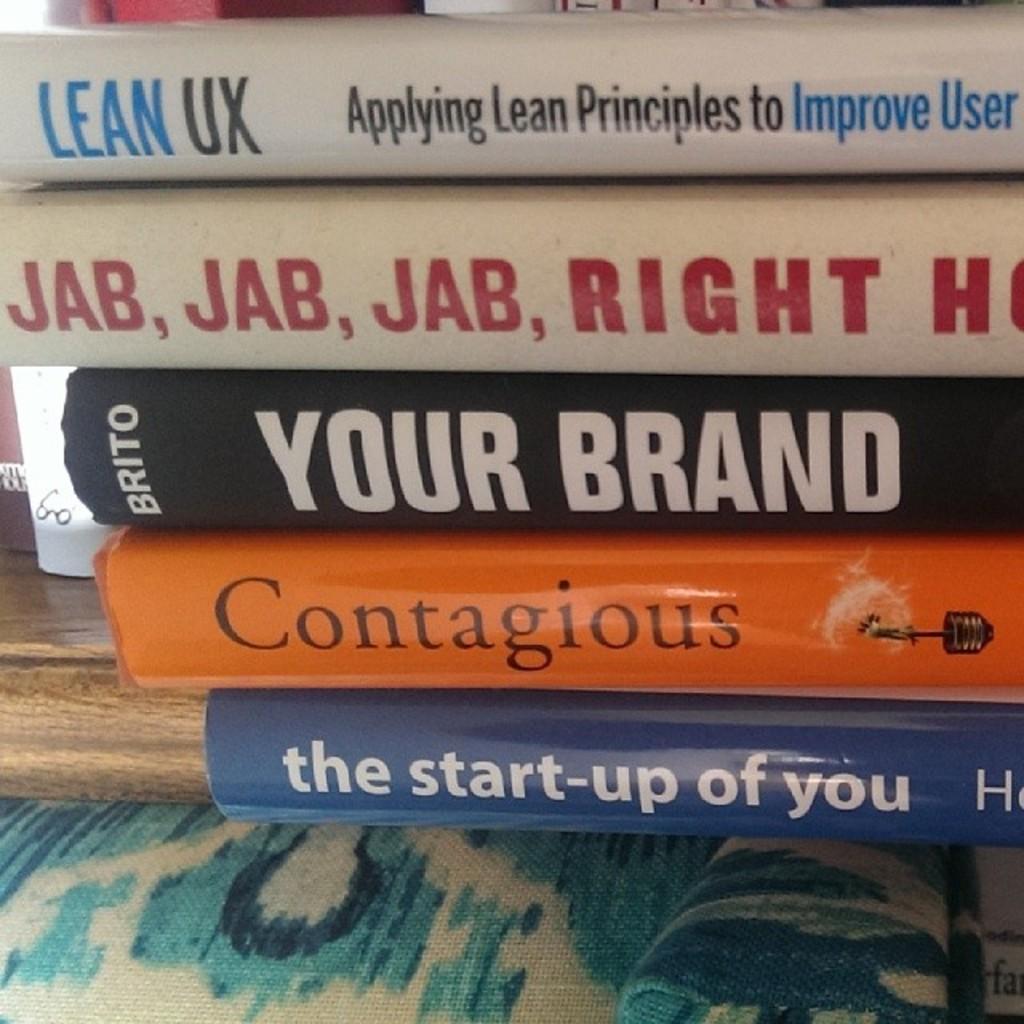What is the title of the orange book?
Offer a terse response. Contagious. 